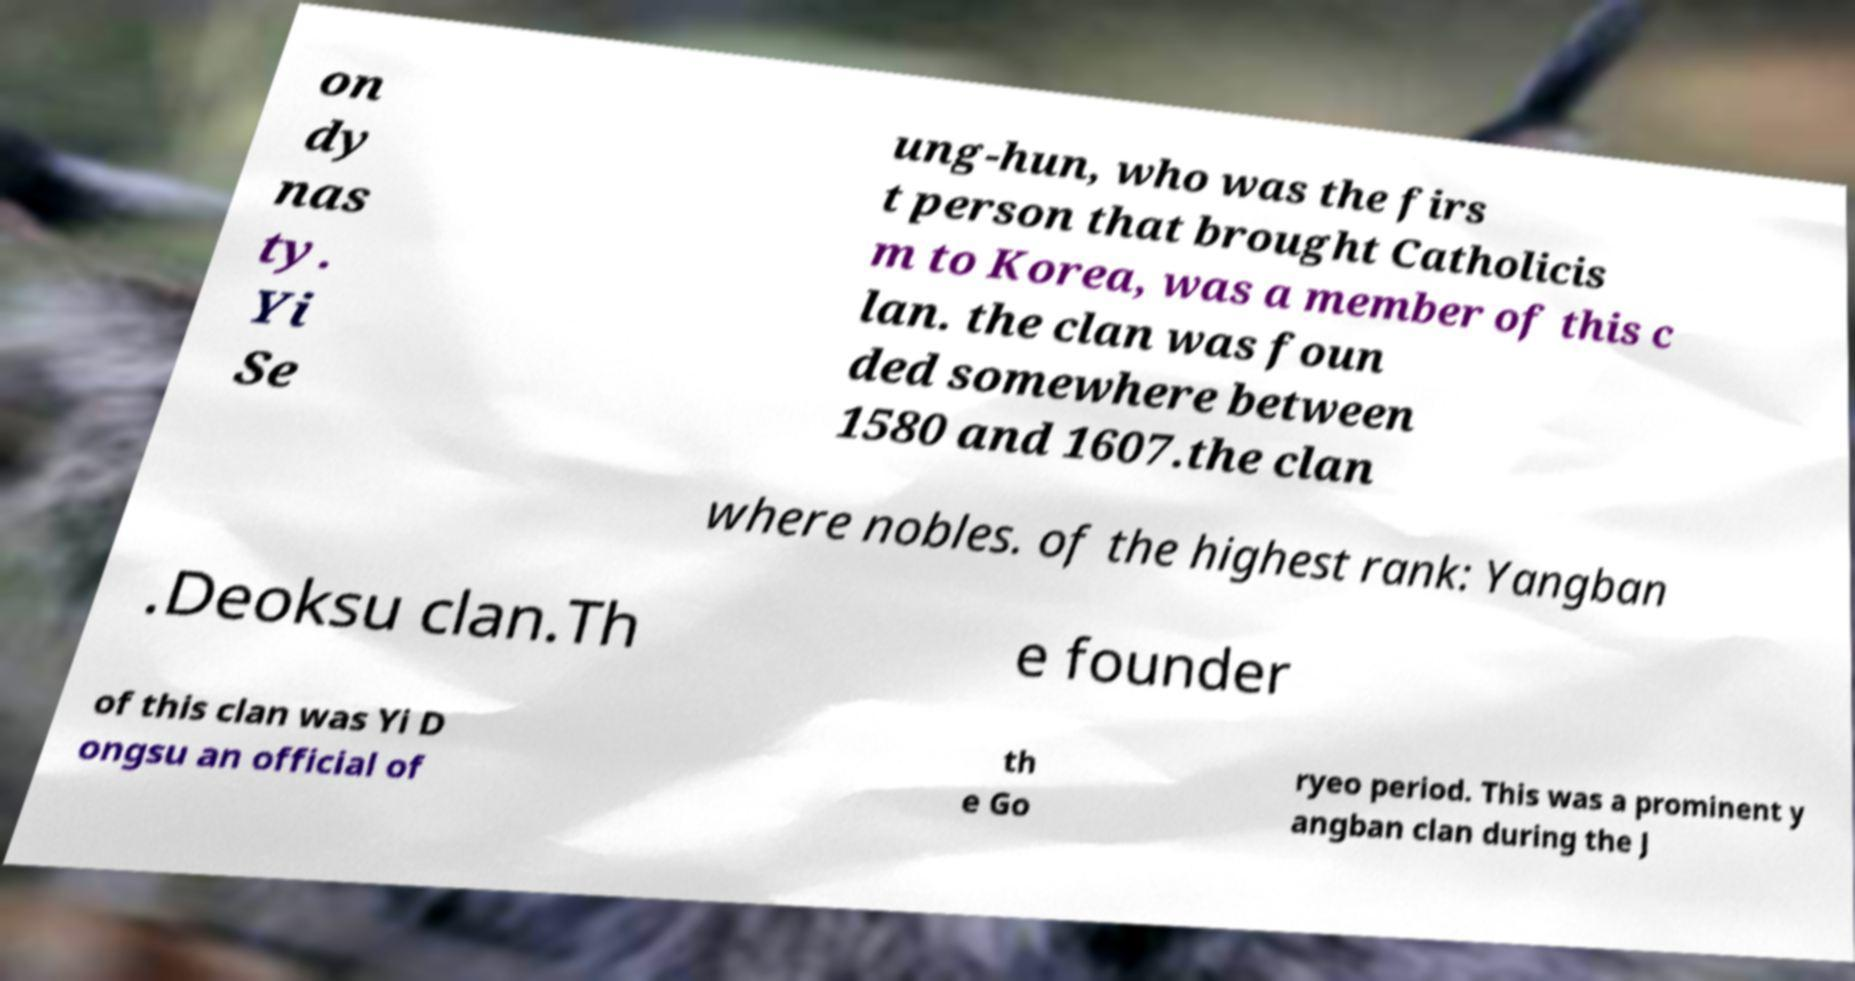I need the written content from this picture converted into text. Can you do that? on dy nas ty. Yi Se ung-hun, who was the firs t person that brought Catholicis m to Korea, was a member of this c lan. the clan was foun ded somewhere between 1580 and 1607.the clan where nobles. of the highest rank: Yangban .Deoksu clan.Th e founder of this clan was Yi D ongsu an official of th e Go ryeo period. This was a prominent y angban clan during the J 